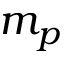<formula> <loc_0><loc_0><loc_500><loc_500>m _ { p }</formula> 